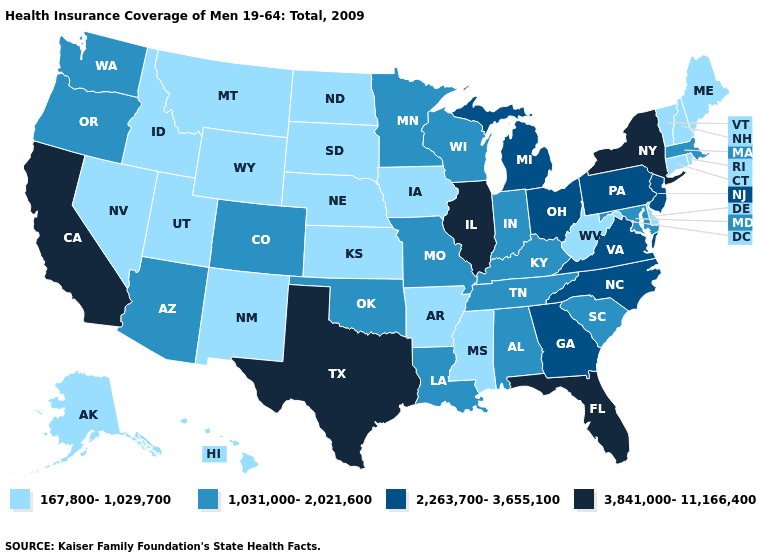What is the lowest value in the USA?
Be succinct. 167,800-1,029,700. Which states have the lowest value in the USA?
Quick response, please. Alaska, Arkansas, Connecticut, Delaware, Hawaii, Idaho, Iowa, Kansas, Maine, Mississippi, Montana, Nebraska, Nevada, New Hampshire, New Mexico, North Dakota, Rhode Island, South Dakota, Utah, Vermont, West Virginia, Wyoming. Does Delaware have the lowest value in the USA?
Write a very short answer. Yes. Does Alaska have the highest value in the USA?
Be succinct. No. Name the states that have a value in the range 2,263,700-3,655,100?
Write a very short answer. Georgia, Michigan, New Jersey, North Carolina, Ohio, Pennsylvania, Virginia. Name the states that have a value in the range 3,841,000-11,166,400?
Short answer required. California, Florida, Illinois, New York, Texas. Which states have the lowest value in the MidWest?
Concise answer only. Iowa, Kansas, Nebraska, North Dakota, South Dakota. How many symbols are there in the legend?
Short answer required. 4. Among the states that border Indiana , which have the lowest value?
Be succinct. Kentucky. Name the states that have a value in the range 167,800-1,029,700?
Short answer required. Alaska, Arkansas, Connecticut, Delaware, Hawaii, Idaho, Iowa, Kansas, Maine, Mississippi, Montana, Nebraska, Nevada, New Hampshire, New Mexico, North Dakota, Rhode Island, South Dakota, Utah, Vermont, West Virginia, Wyoming. What is the value of Oregon?
Concise answer only. 1,031,000-2,021,600. Does Florida have the highest value in the USA?
Quick response, please. Yes. What is the highest value in states that border Michigan?
Write a very short answer. 2,263,700-3,655,100. Which states have the highest value in the USA?
Be succinct. California, Florida, Illinois, New York, Texas. Does Florida have the same value as New York?
Keep it brief. Yes. 